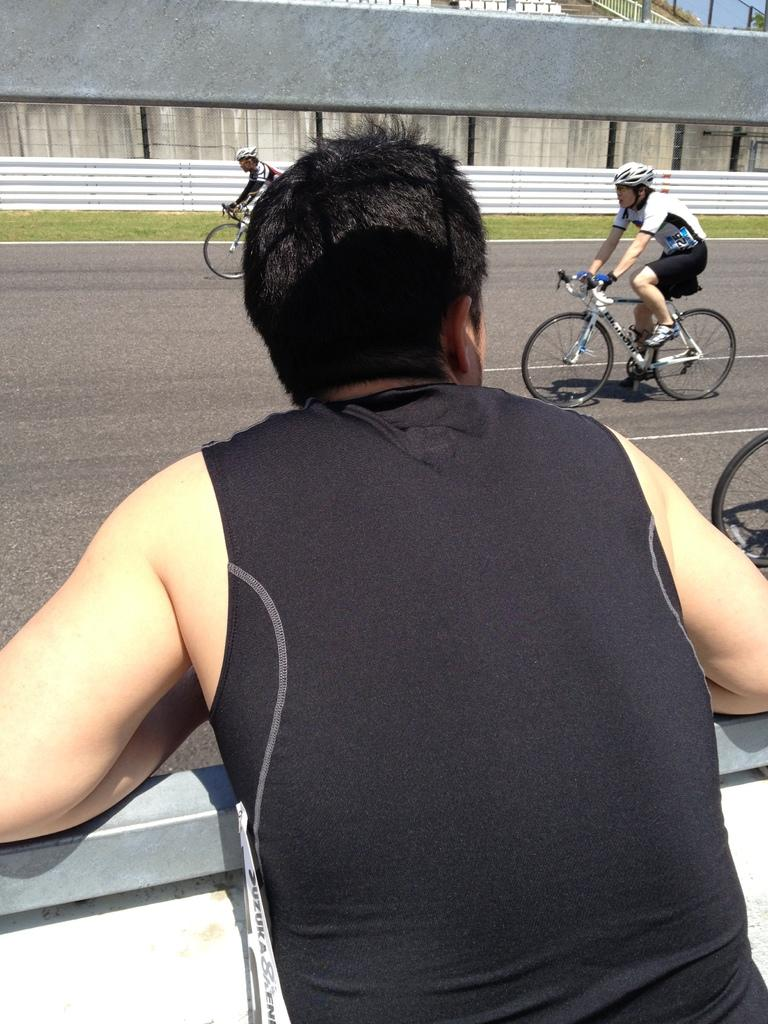What is the main subject of the image? There is a person standing in the image. What are the other people in the image doing? There is a group of people riding bicycles in the image. Where are the people riding their bicycles? The people are riding their bicycles on a road. What type of vegetation can be seen in the image? There is grass visible in the image. What type of care can be seen being provided to the toys in the image? There are no toys present in the image, so no care is being provided to them. 